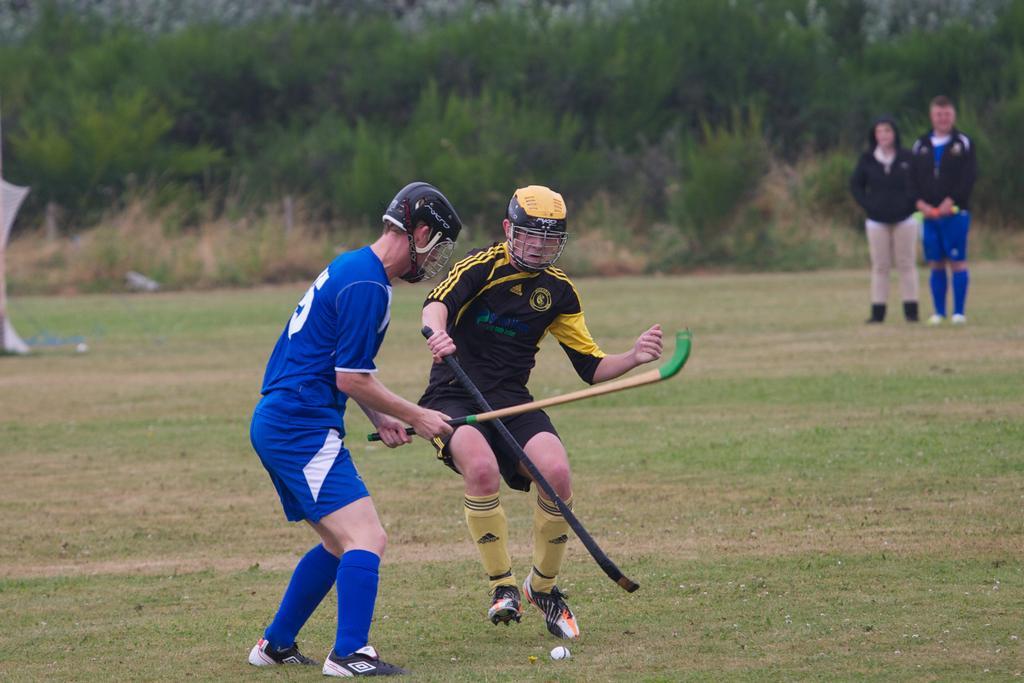Could you give a brief overview of what you see in this image? In this picture we can see two people wore helmets, shoes and holding bats with their hands and in front of them we can see a ball on the ground and in the background we can see an object, two people standing, grass, plants and trees. 